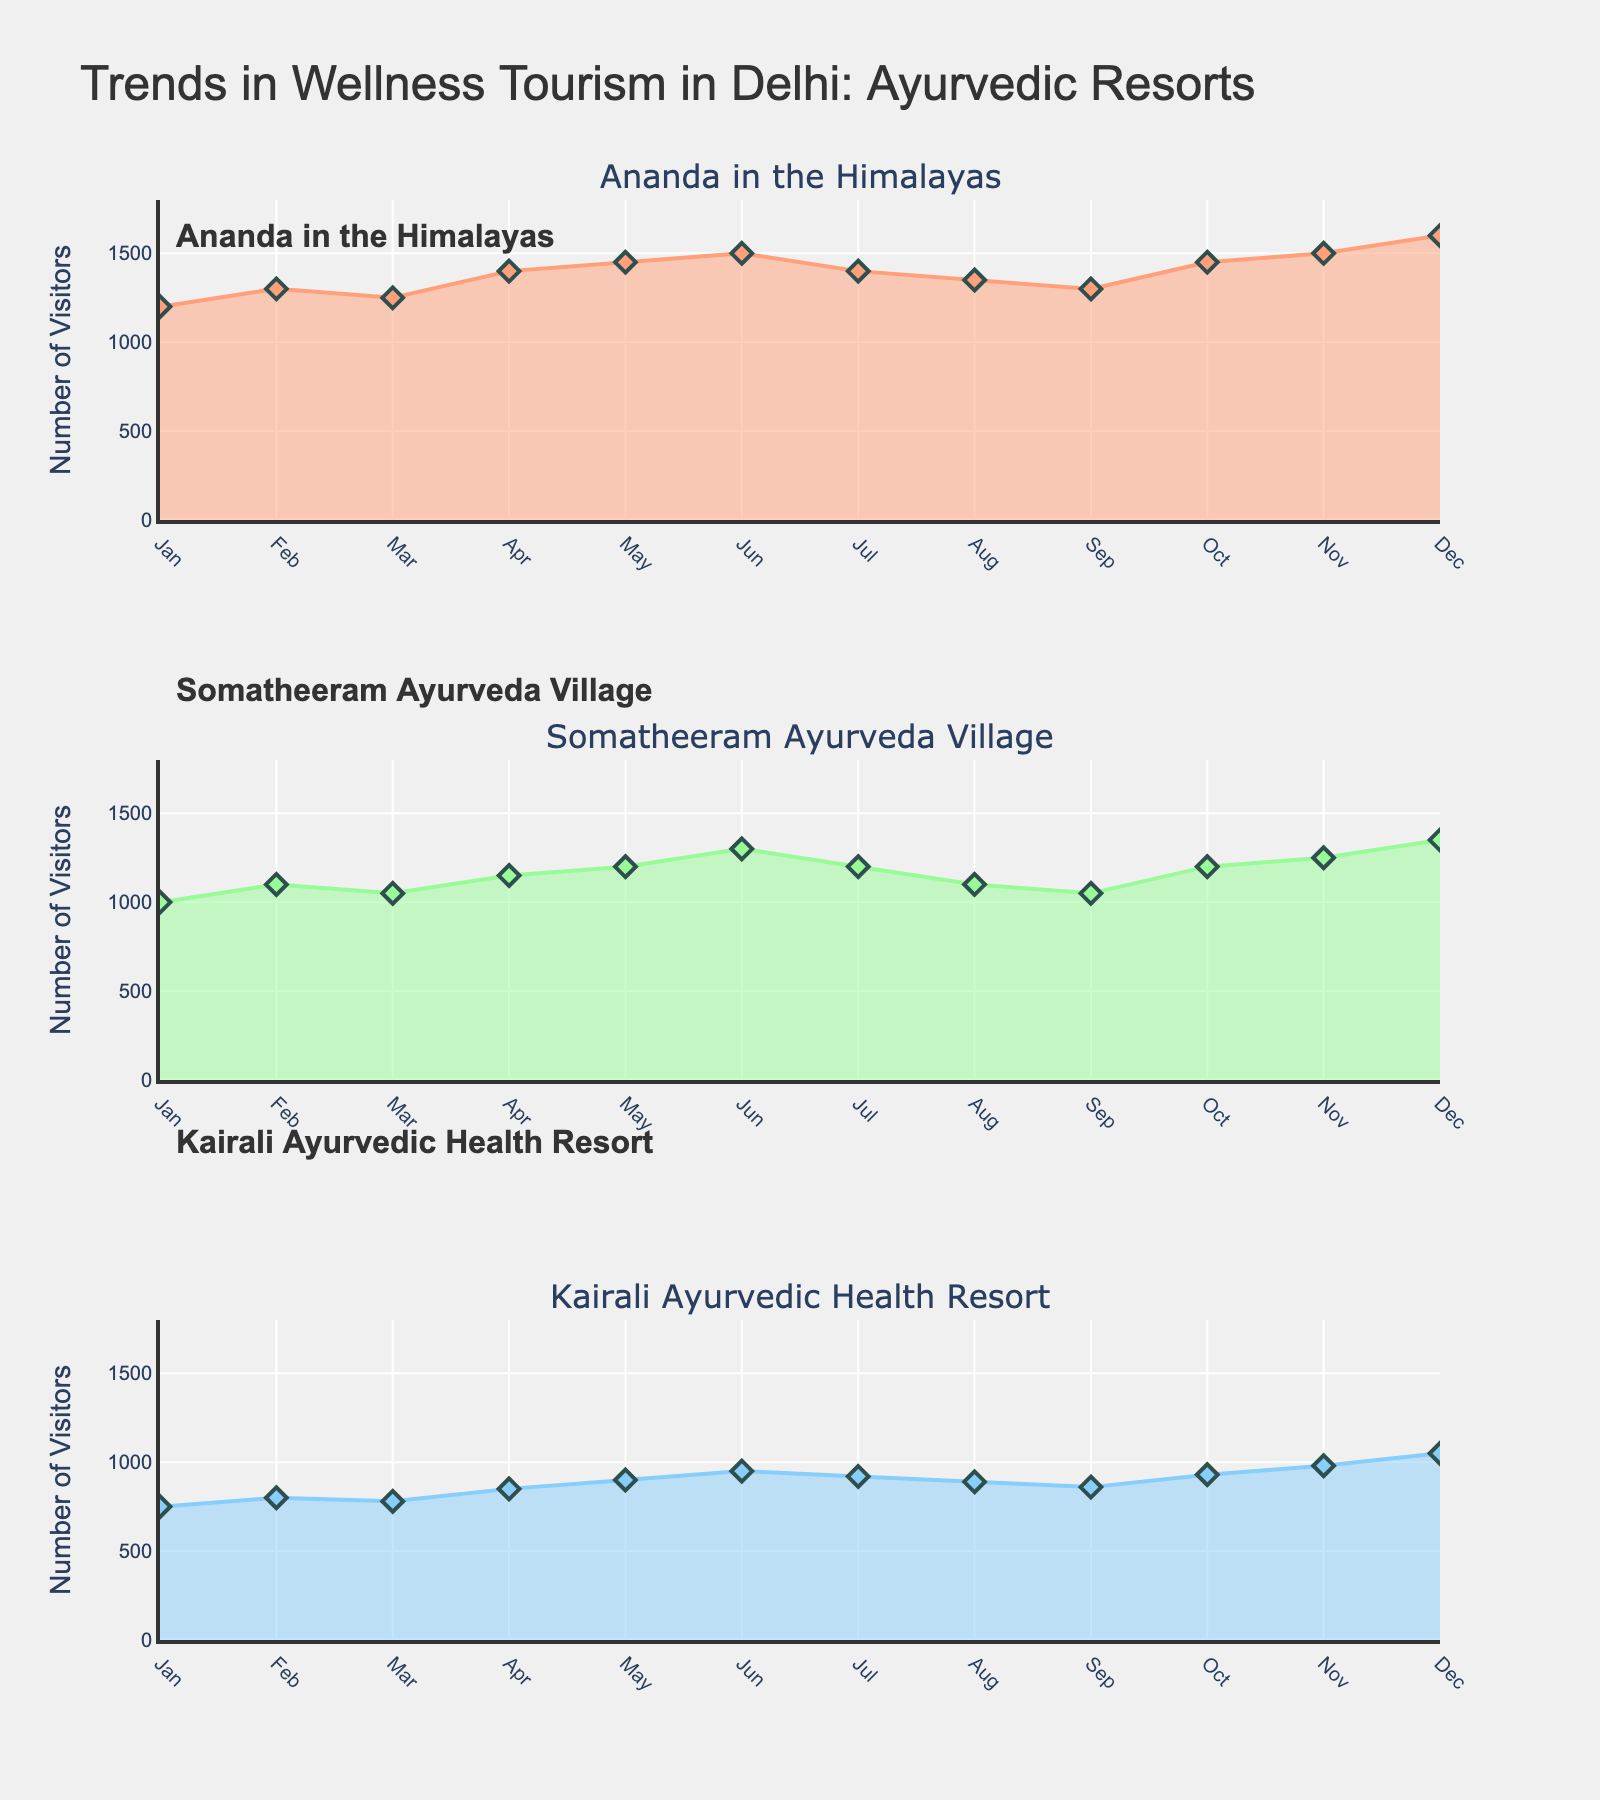What is the title of the chart? The title of the chart is located at the top and says "Trends in Wellness Tourism in Delhi: Ayurvedic Resorts"
Answer: Trends in Wellness Tourism in Delhi: Ayurvedic Resorts How many subplots are there in the figure? The figure is divided into three subplots corresponding to each resort mentioned in the dataset.
Answer: 3 Which resort had the highest number of visitors in December? Look at the December data points in all three subplots and compare the visitor numbers. "Ananda in the Himalayas" had 1600 visitors in December, which is the highest.
Answer: Ananda in the Himalayas In which month did Somatheeram Ayurveda Village have the lowest number of visitors? Look at the Somatheeram Ayurveda Village subplot and find the month with the lowest data point. The lowest number is 1000 visitors in January.
Answer: January What were the total number of visitors for Kairali Ayurvedic Health Resort in the first half of the year (Jan to Jun)? Sum the data points for Kairali Ayurvedic Health Resort from January to June: 750 + 800 + 780 + 850 + 900 + 950 = 5030 visitors.
Answer: 5030 During which months did all three resorts experience an increase in the number of visitors? Look at all three subplots and identify the months where each resort's line rises from the previous month. In April, May, and November, all the resorts experienced an uptick.
Answer: April, May, November How does the visitor trend in July for Ananda in the Himalayas compare to Kairali Ayurvedic Health Resort? In July, the visitor count for Ananda in the Himalayas decreases slightly compared to June, while Kairali Ayurvedic Health Resort also sees a slight decrease.
Answer: Both decreased Which resort had the steadiest number of visitors throughout the year? Observing the trends, Kairali Ayurvedic Health Resort has the least variation in its data points with a consistent range, showing it is the steadiest.
Answer: Kairali Ayurvedic Health Resort How many resorts experienced a peak number of visitors in June? Look at each subplot and identify if the June data point is the highest. Ananda in the Himalayas and Somatheeram Ayurveda Village both peaked in June.
Answer: 2 What is the approximate average number of visitors in October for the three resorts combined? Sum the visitor numbers for October across the three resorts and then divide by three: (1450 + 1200 + 930) / 3 = 3580 / 3 ≈ 1193
Answer: 1193 